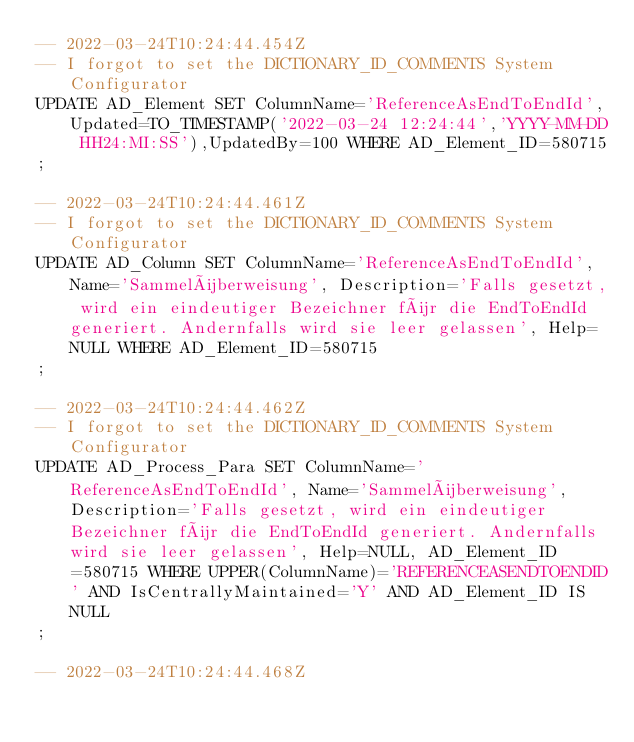Convert code to text. <code><loc_0><loc_0><loc_500><loc_500><_SQL_>-- 2022-03-24T10:24:44.454Z
-- I forgot to set the DICTIONARY_ID_COMMENTS System Configurator
UPDATE AD_Element SET ColumnName='ReferenceAsEndToEndId',Updated=TO_TIMESTAMP('2022-03-24 12:24:44','YYYY-MM-DD HH24:MI:SS'),UpdatedBy=100 WHERE AD_Element_ID=580715
;

-- 2022-03-24T10:24:44.461Z
-- I forgot to set the DICTIONARY_ID_COMMENTS System Configurator
UPDATE AD_Column SET ColumnName='ReferenceAsEndToEndId', Name='Sammelüberweisung', Description='Falls gesetzt, wird ein eindeutiger Bezeichner für die EndToEndId generiert. Andernfalls wird sie leer gelassen', Help=NULL WHERE AD_Element_ID=580715
;

-- 2022-03-24T10:24:44.462Z
-- I forgot to set the DICTIONARY_ID_COMMENTS System Configurator
UPDATE AD_Process_Para SET ColumnName='ReferenceAsEndToEndId', Name='Sammelüberweisung', Description='Falls gesetzt, wird ein eindeutiger Bezeichner für die EndToEndId generiert. Andernfalls wird sie leer gelassen', Help=NULL, AD_Element_ID=580715 WHERE UPPER(ColumnName)='REFERENCEASENDTOENDID' AND IsCentrallyMaintained='Y' AND AD_Element_ID IS NULL
;

-- 2022-03-24T10:24:44.468Z</code> 